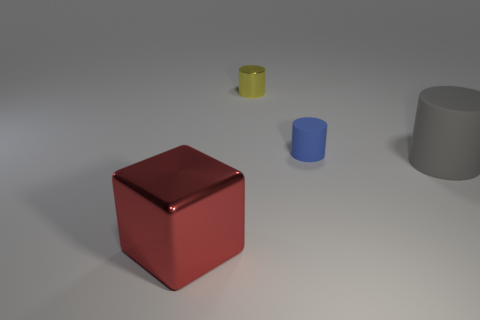There is a metal cylinder that is the same size as the blue thing; what color is it?
Give a very brief answer. Yellow. What number of tiny green rubber spheres are there?
Provide a succinct answer. 0. Is the material of the blue cylinder behind the large matte thing the same as the big block?
Your answer should be compact. No. The thing that is to the right of the small metallic thing and left of the gray cylinder is made of what material?
Offer a terse response. Rubber. What material is the object in front of the large thing to the right of the big red block?
Keep it short and to the point. Metal. How big is the metal object on the right side of the shiny object left of the thing behind the small blue thing?
Your answer should be very brief. Small. How many tiny things have the same material as the yellow cylinder?
Offer a terse response. 0. There is a shiny cylinder left of the big thing that is on the right side of the big cube; what color is it?
Your answer should be compact. Yellow. How many things are red blocks or objects that are in front of the gray matte cylinder?
Offer a very short reply. 1. Are there any balls that have the same color as the metal cylinder?
Your response must be concise. No. 